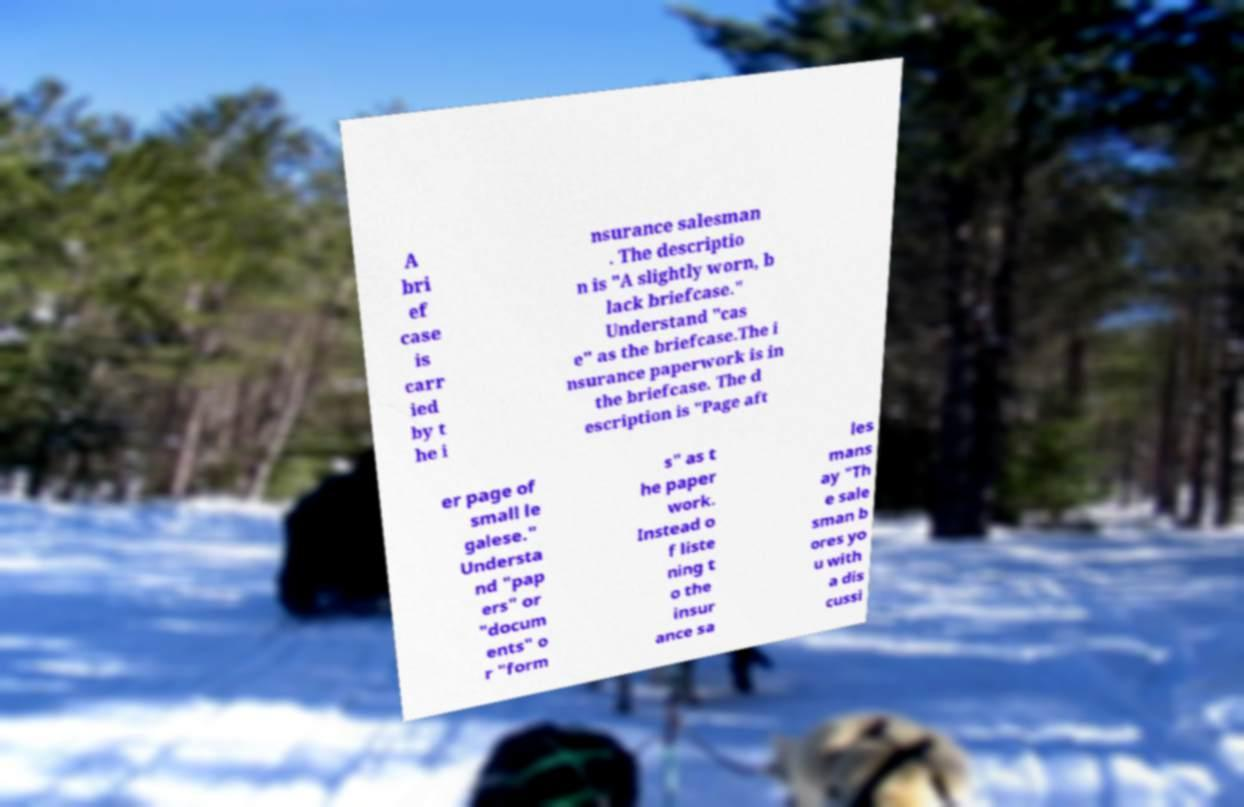Please identify and transcribe the text found in this image. A bri ef case is carr ied by t he i nsurance salesman . The descriptio n is "A slightly worn, b lack briefcase." Understand "cas e" as the briefcase.The i nsurance paperwork is in the briefcase. The d escription is "Page aft er page of small le galese." Understa nd "pap ers" or "docum ents" o r "form s" as t he paper work. Instead o f liste ning t o the insur ance sa les mans ay "Th e sale sman b ores yo u with a dis cussi 